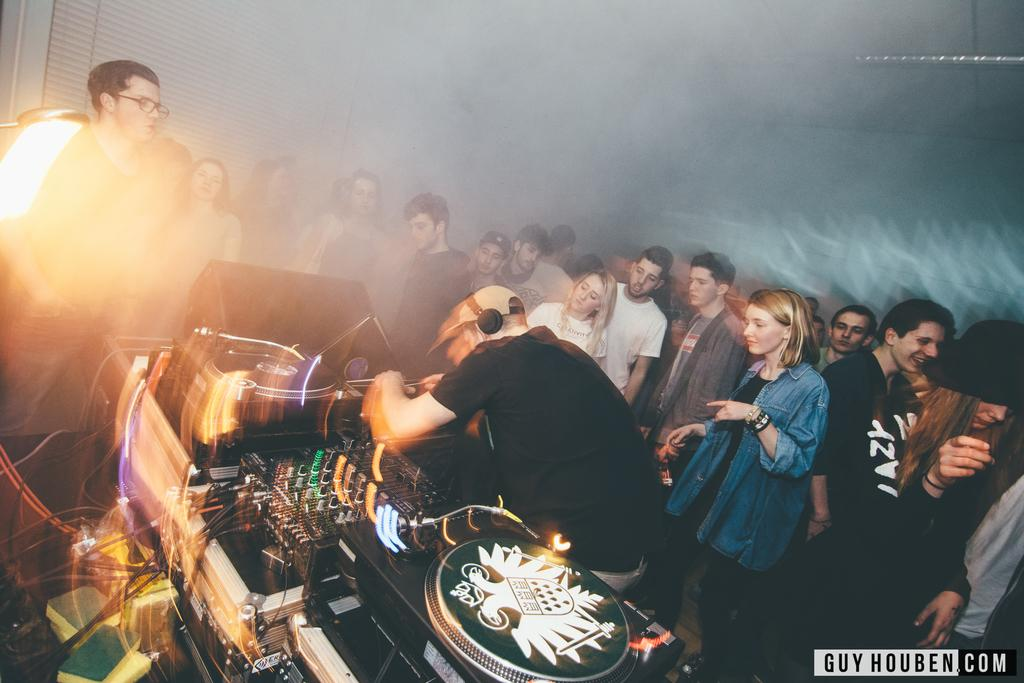How many people are in the room? There are people in the room, but the exact number is not specified. What is the person with headphones doing? The person with headphones is near a music player, which suggests they might be listening to music. What is on the left side of the room? There is a window shade on the left side of the room. What type of lighting is present in the room? There is a light on the ceiling. What type of meat is being cooked on the stove in the image? There is no stove or meat present in the image. How many legs can be seen in the image? The number of legs visible in the image is not mentioned in the facts provided. 